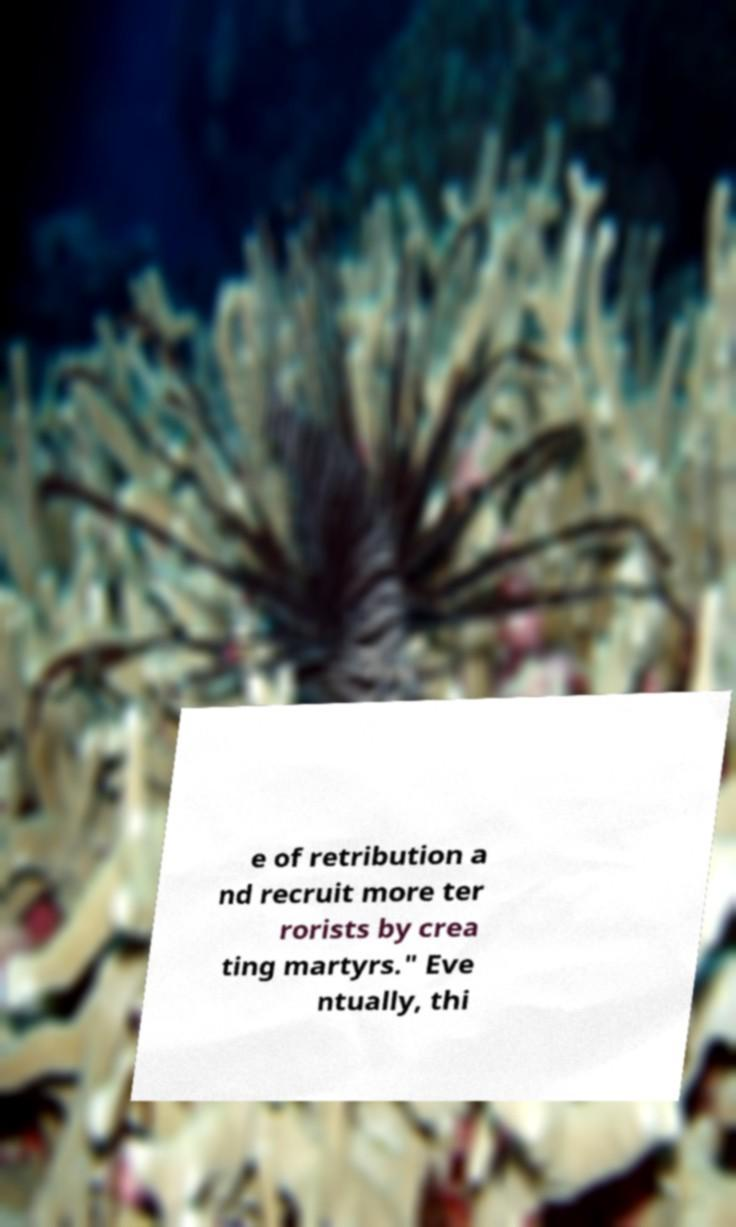Please identify and transcribe the text found in this image. e of retribution a nd recruit more ter rorists by crea ting martyrs." Eve ntually, thi 